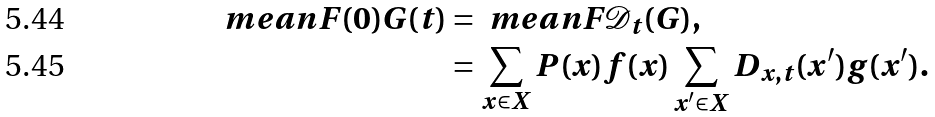Convert formula to latex. <formula><loc_0><loc_0><loc_500><loc_500>\ m e a n { F ( 0 ) G ( t ) } & = \ m e a n { F \mathcal { D } _ { t } ( G ) } , \\ & = \sum _ { x \in X } P ( x ) f ( x ) \sum _ { x ^ { \prime } \in X } D _ { x , t } ( x ^ { \prime } ) g ( x ^ { \prime } ) .</formula> 